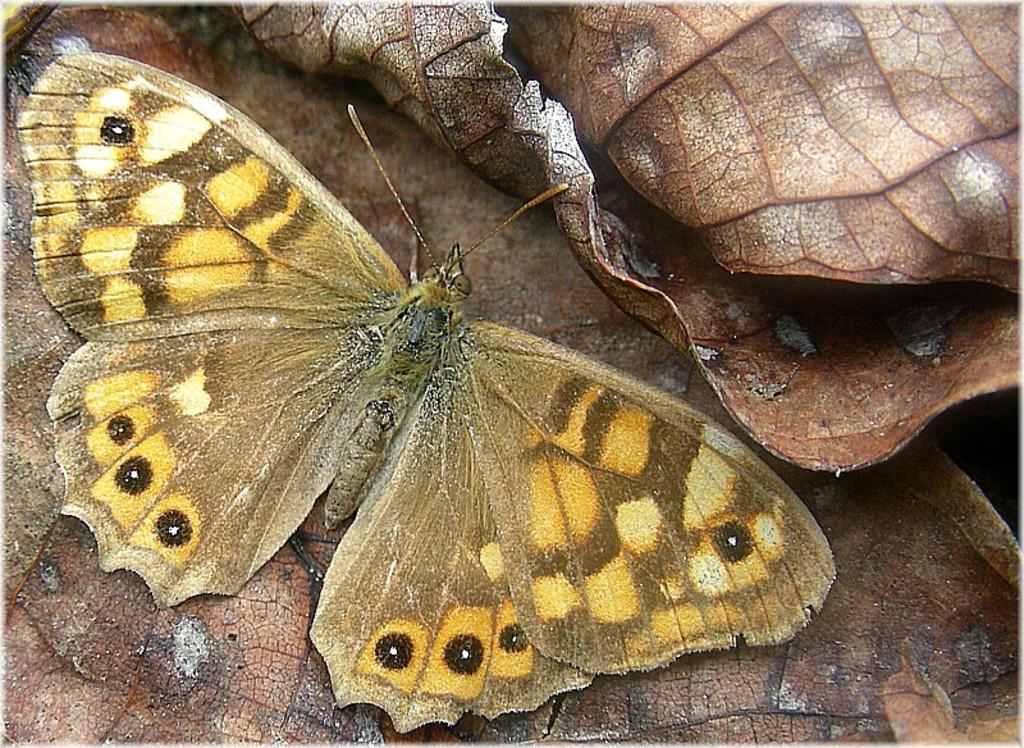What is the main subject of the image? There is a butterfly in the image. Where is the butterfly located in the image? The butterfly is on the leaves. What word is the butterfly saying in the image? Butterflies do not have the ability to speak or say words, so there is no word being said by the butterfly in the image. 